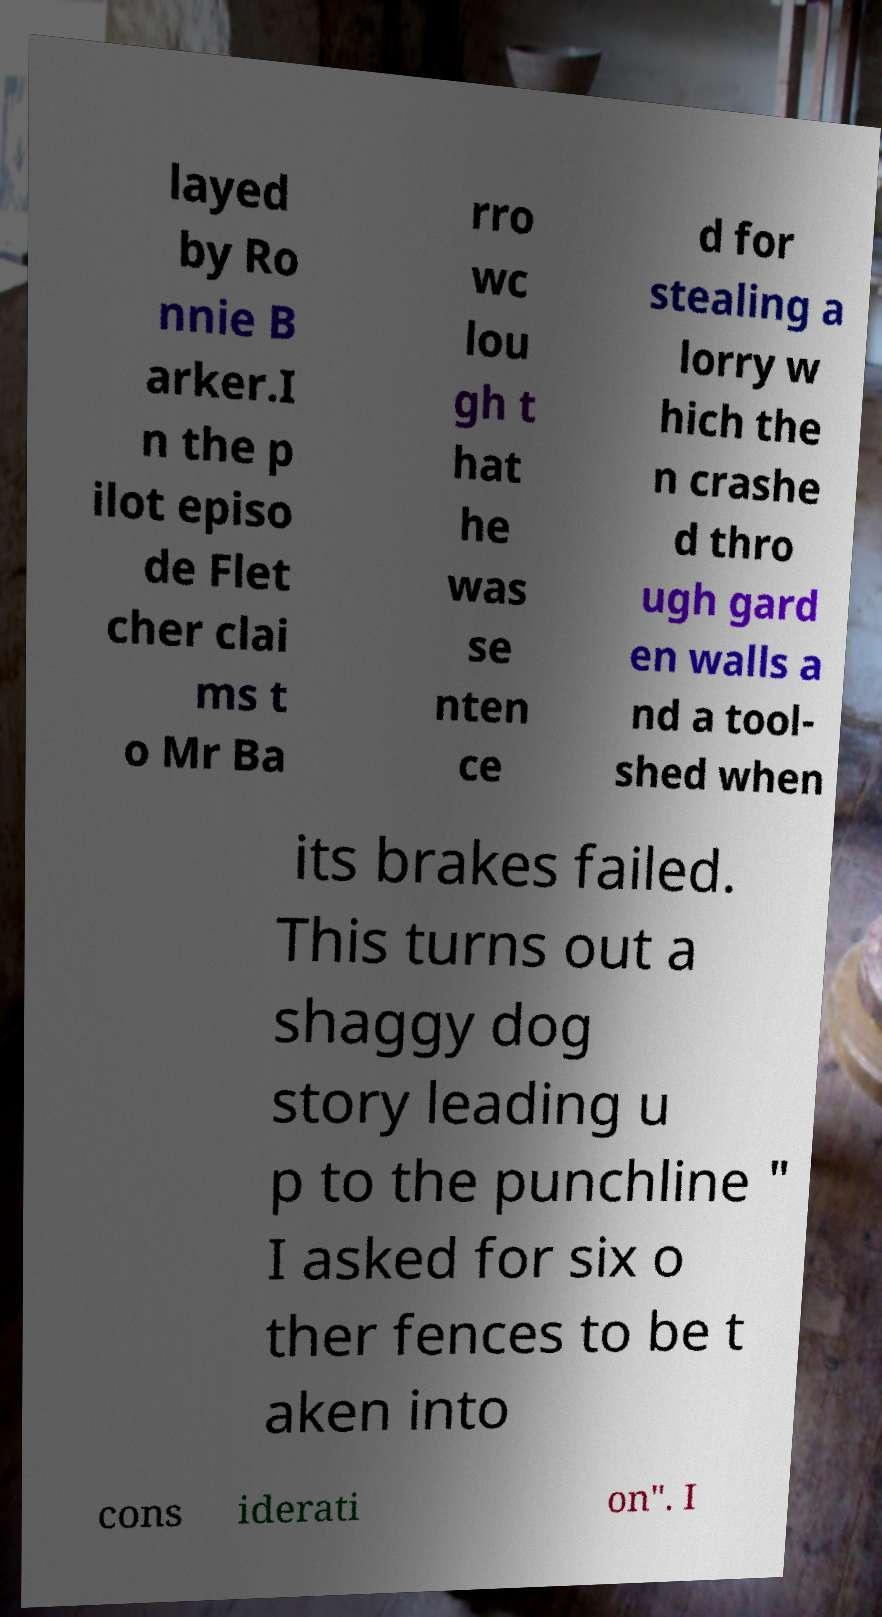I need the written content from this picture converted into text. Can you do that? layed by Ro nnie B arker.I n the p ilot episo de Flet cher clai ms t o Mr Ba rro wc lou gh t hat he was se nten ce d for stealing a lorry w hich the n crashe d thro ugh gard en walls a nd a tool- shed when its brakes failed. This turns out a shaggy dog story leading u p to the punchline " I asked for six o ther fences to be t aken into cons iderati on". I 